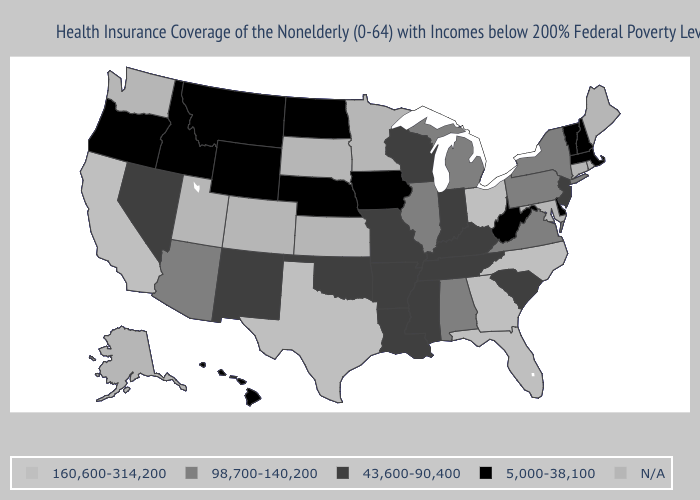Which states hav the highest value in the West?
Answer briefly. California. Does Wisconsin have the lowest value in the USA?
Answer briefly. No. What is the lowest value in the USA?
Write a very short answer. 5,000-38,100. What is the value of Idaho?
Write a very short answer. 5,000-38,100. Name the states that have a value in the range 160,600-314,200?
Short answer required. California, Florida, Georgia, North Carolina, Ohio, Texas. What is the highest value in the South ?
Short answer required. 160,600-314,200. How many symbols are there in the legend?
Give a very brief answer. 5. Name the states that have a value in the range 43,600-90,400?
Concise answer only. Arkansas, Indiana, Kentucky, Louisiana, Mississippi, Missouri, Nevada, New Jersey, New Mexico, Oklahoma, South Carolina, Tennessee, Wisconsin. Does the map have missing data?
Quick response, please. Yes. Name the states that have a value in the range 43,600-90,400?
Give a very brief answer. Arkansas, Indiana, Kentucky, Louisiana, Mississippi, Missouri, Nevada, New Jersey, New Mexico, Oklahoma, South Carolina, Tennessee, Wisconsin. Is the legend a continuous bar?
Quick response, please. No. Name the states that have a value in the range N/A?
Keep it brief. Alaska, Colorado, Connecticut, Kansas, Maine, Maryland, Minnesota, Rhode Island, South Dakota, Utah, Washington. Name the states that have a value in the range 98,700-140,200?
Give a very brief answer. Alabama, Arizona, Illinois, Michigan, New York, Pennsylvania, Virginia. What is the value of Utah?
Be succinct. N/A. What is the value of Alabama?
Concise answer only. 98,700-140,200. 